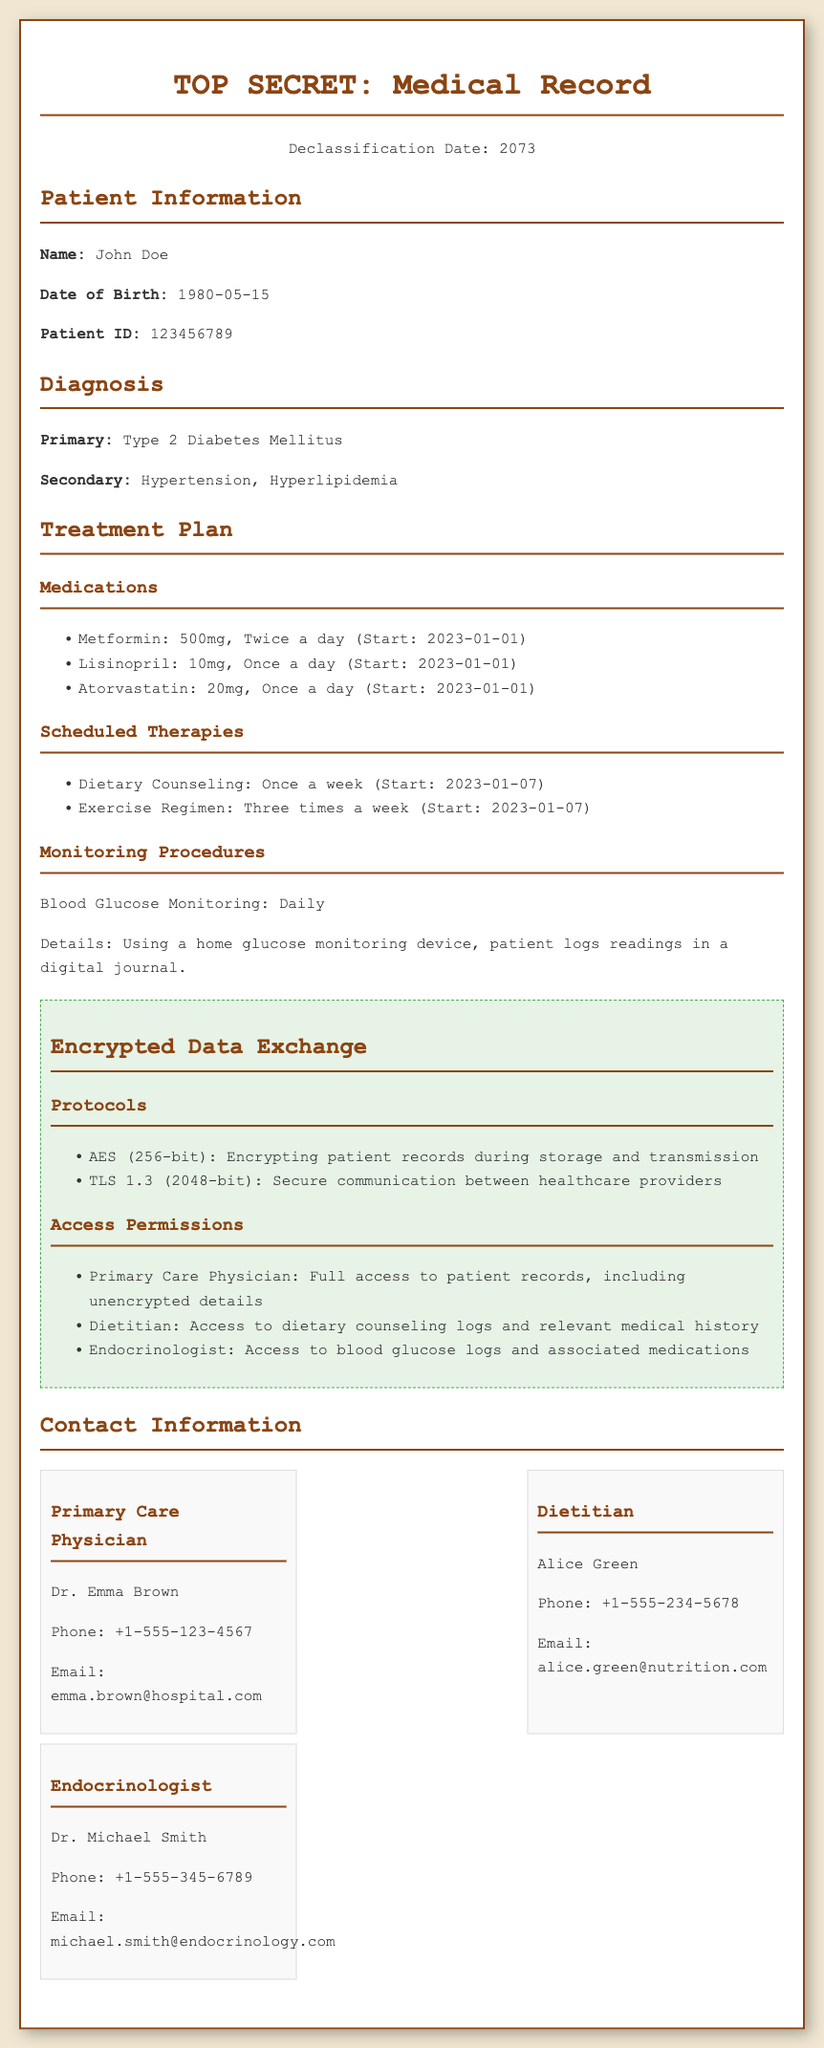What is the patient's name? The document provides the patient's name in the Patient Information section.
Answer: John Doe What is the prescribed medication for hypertension? The treatment plan lists specific medications for the patient's diagnosis of hypertension.
Answer: Lisinopril How often should blood glucose be monitored? The document specifies the frequency of monitoring procedures for the patient's blood glucose levels.
Answer: Daily Who is the primary care physician? The contact information section identifies the primary care physician for the patient.
Answer: Dr. Emma Brown What encryption protocol is used for secure communication? The Encrypted Data Exchange section lists the protocols used for data protection between healthcare providers.
Answer: TLS 1.3 (2048-bit) When did dietary counseling begin? The Scheduled Therapies section indicates the start date for dietary counseling sessions.
Answer: 2023-01-07 What is the start date for exercise regimen? The Scheduled Therapies section provides detailed information on when the exercise program begins.
Answer: 2023-01-07 Which medication is prescribed twice a day? The Medications section outlines how often each medication should be taken.
Answer: Metformin 